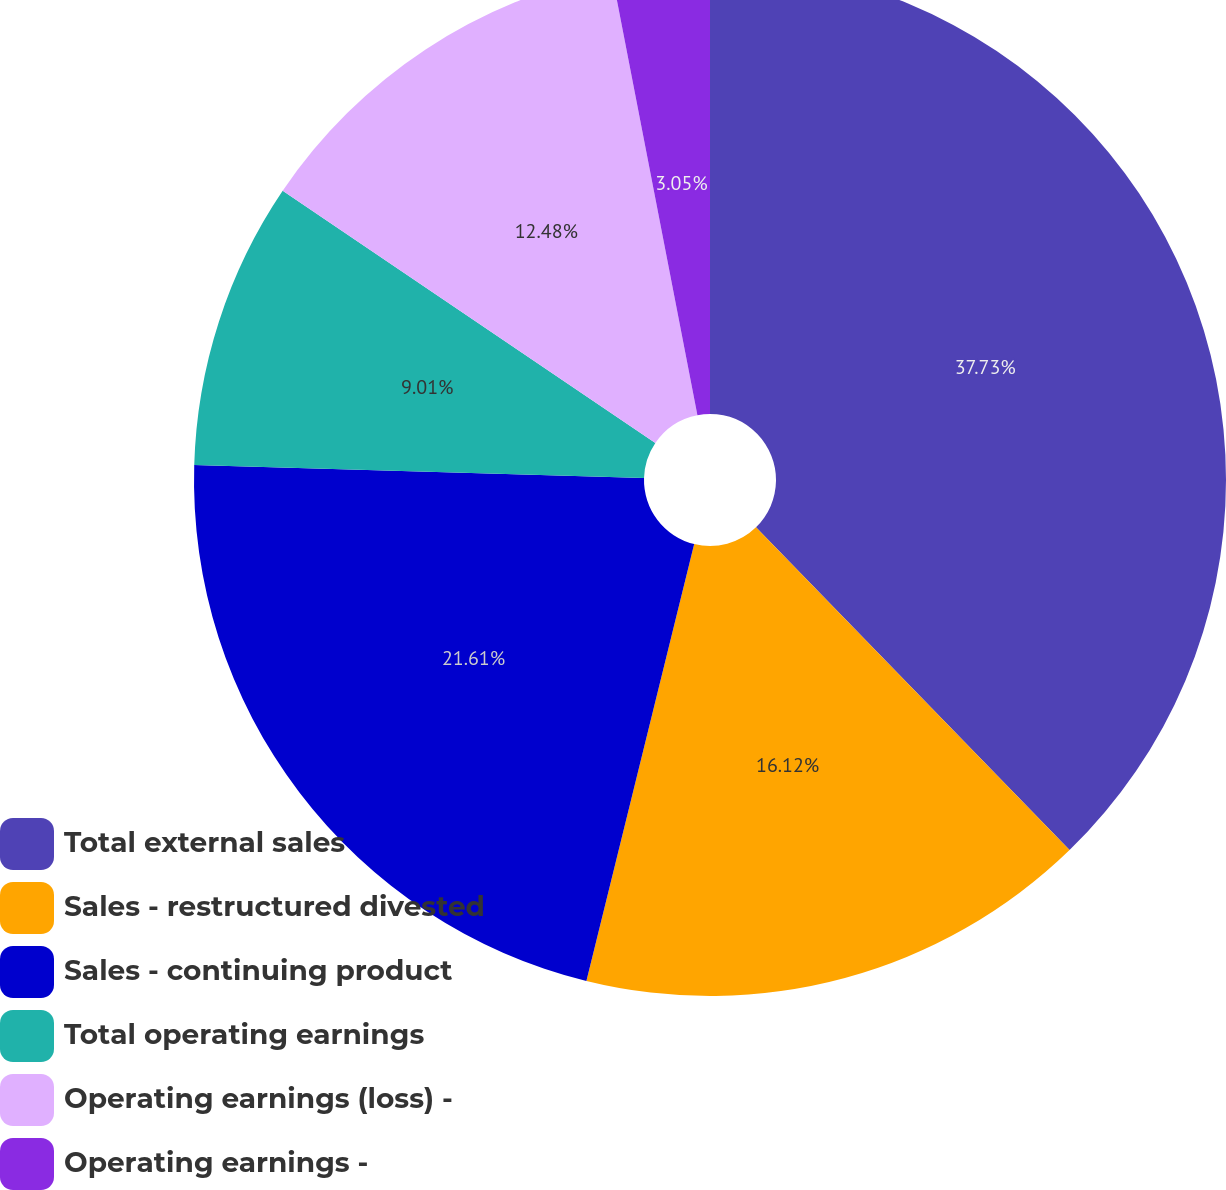Convert chart to OTSL. <chart><loc_0><loc_0><loc_500><loc_500><pie_chart><fcel>Total external sales<fcel>Sales - restructured divested<fcel>Sales - continuing product<fcel>Total operating earnings<fcel>Operating earnings (loss) -<fcel>Operating earnings -<nl><fcel>37.73%<fcel>16.12%<fcel>21.61%<fcel>9.01%<fcel>12.48%<fcel>3.05%<nl></chart> 